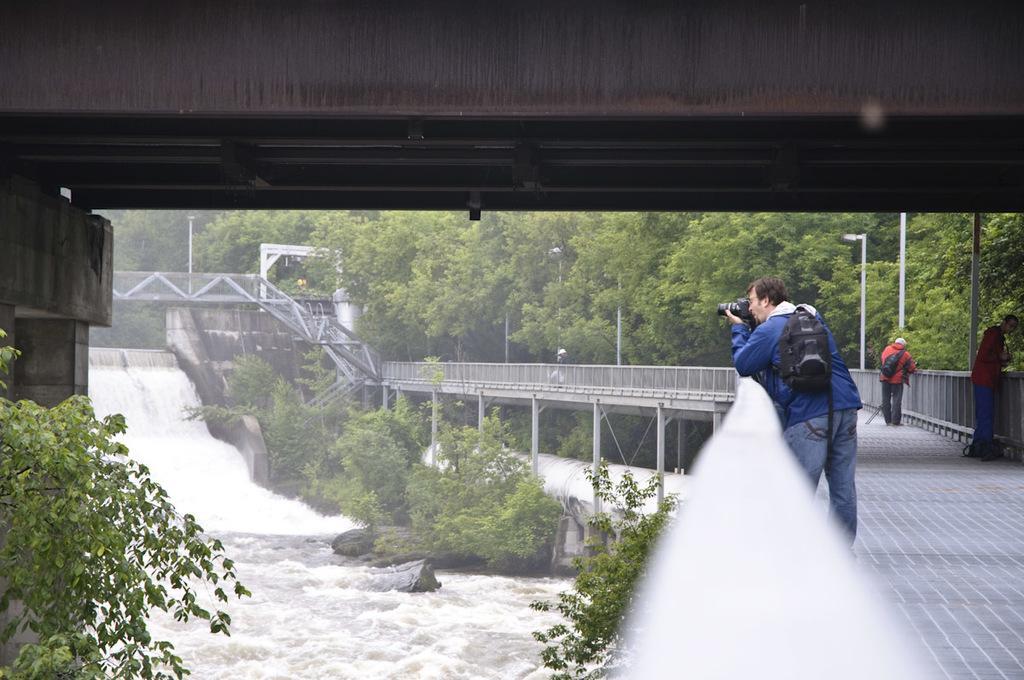Can you describe this image briefly? There are people and this man holding a camera and carrying bag. We can see fences, water, trees, rocks, bridge and poles. 